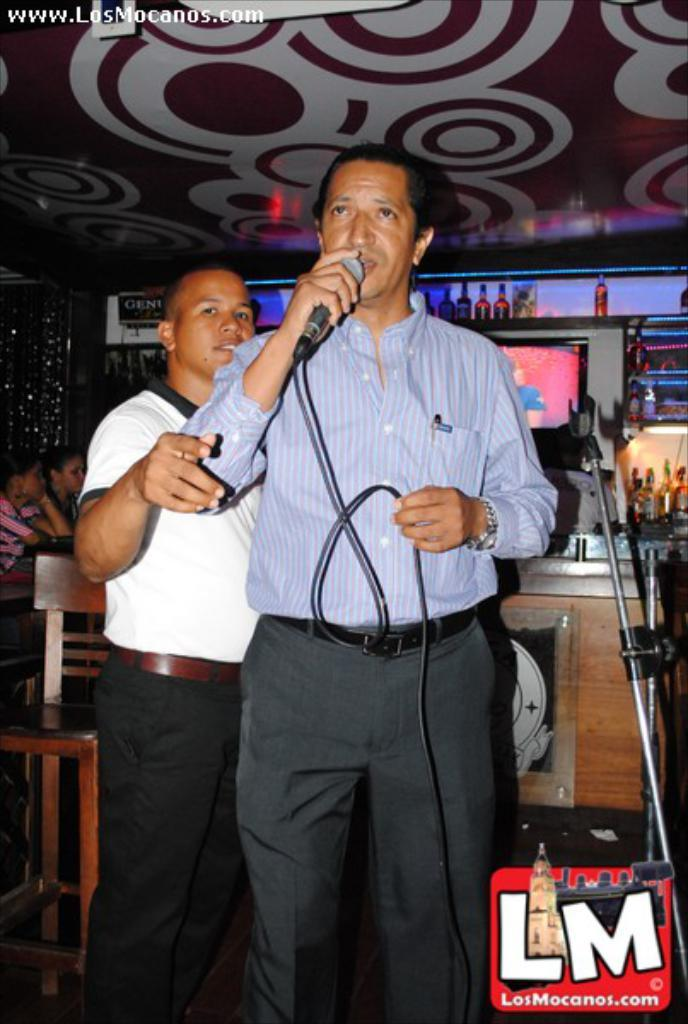How many people are in the image? There are two people in the image. What is one of the people holding? One of the people is holding a microphone. What type of furniture is present in the image? There are chairs and a table in the image. Can you describe any other objects or features in the image? There are other unspecified things in the image. What type of bread is being offered as advice in the image? There is no bread or advice present in the image. 